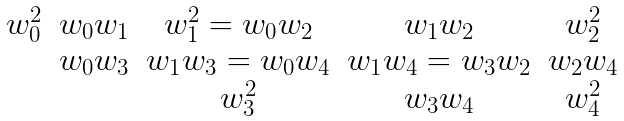Convert formula to latex. <formula><loc_0><loc_0><loc_500><loc_500>\begin{array} { c c c c c } w _ { 0 } ^ { 2 } & w _ { 0 } w _ { 1 } & w _ { 1 } ^ { 2 } = w _ { 0 } w _ { 2 } & w _ { 1 } w _ { 2 } & w _ { 2 } ^ { 2 } \\ & w _ { 0 } w _ { 3 } & w _ { 1 } w _ { 3 } = w _ { 0 } w _ { 4 } & w _ { 1 } w _ { 4 } = w _ { 3 } w _ { 2 } & w _ { 2 } w _ { 4 } \\ & & w _ { 3 } ^ { 2 } & w _ { 3 } w _ { 4 } & w _ { 4 } ^ { 2 } \end{array}</formula> 